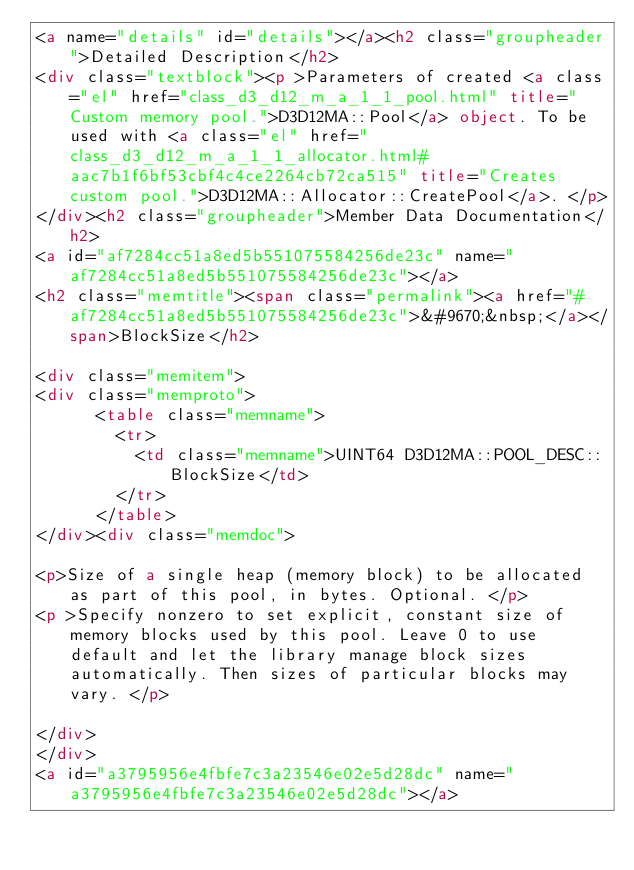<code> <loc_0><loc_0><loc_500><loc_500><_HTML_><a name="details" id="details"></a><h2 class="groupheader">Detailed Description</h2>
<div class="textblock"><p >Parameters of created <a class="el" href="class_d3_d12_m_a_1_1_pool.html" title="Custom memory pool.">D3D12MA::Pool</a> object. To be used with <a class="el" href="class_d3_d12_m_a_1_1_allocator.html#aac7b1f6bf53cbf4c4ce2264cb72ca515" title="Creates custom pool.">D3D12MA::Allocator::CreatePool</a>. </p>
</div><h2 class="groupheader">Member Data Documentation</h2>
<a id="af7284cc51a8ed5b551075584256de23c" name="af7284cc51a8ed5b551075584256de23c"></a>
<h2 class="memtitle"><span class="permalink"><a href="#af7284cc51a8ed5b551075584256de23c">&#9670;&nbsp;</a></span>BlockSize</h2>

<div class="memitem">
<div class="memproto">
      <table class="memname">
        <tr>
          <td class="memname">UINT64 D3D12MA::POOL_DESC::BlockSize</td>
        </tr>
      </table>
</div><div class="memdoc">

<p>Size of a single heap (memory block) to be allocated as part of this pool, in bytes. Optional. </p>
<p >Specify nonzero to set explicit, constant size of memory blocks used by this pool. Leave 0 to use default and let the library manage block sizes automatically. Then sizes of particular blocks may vary. </p>

</div>
</div>
<a id="a3795956e4fbfe7c3a23546e02e5d28dc" name="a3795956e4fbfe7c3a23546e02e5d28dc"></a></code> 